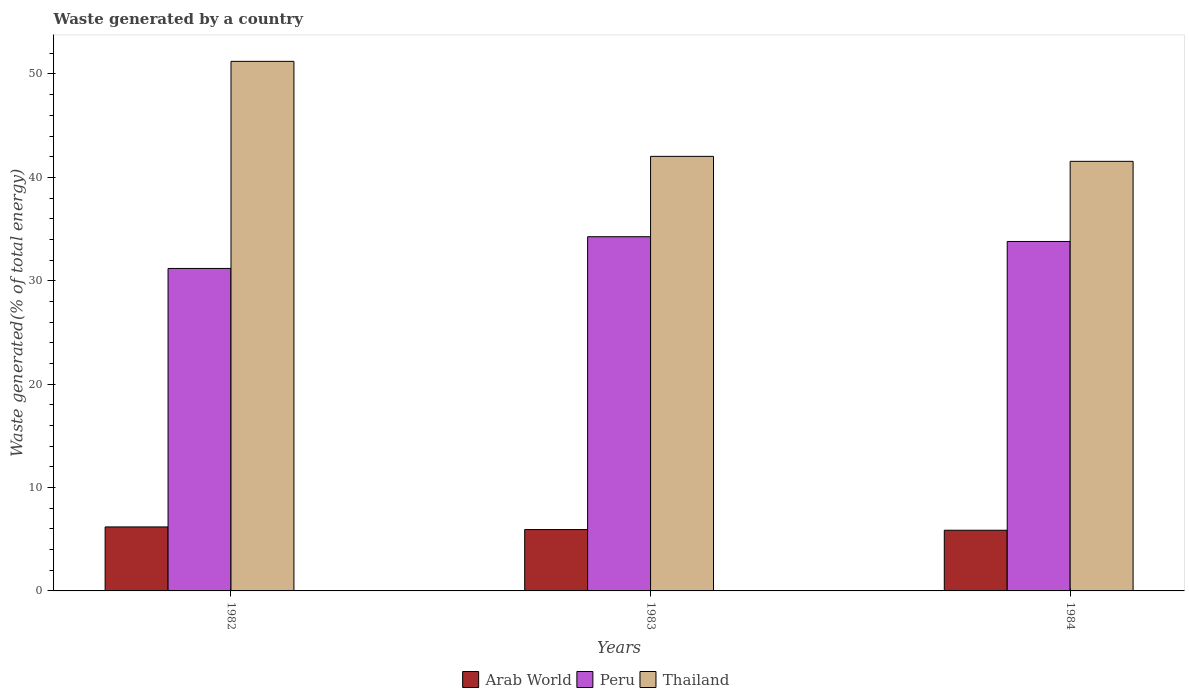How many different coloured bars are there?
Ensure brevity in your answer.  3. Are the number of bars per tick equal to the number of legend labels?
Provide a succinct answer. Yes. How many bars are there on the 2nd tick from the left?
Ensure brevity in your answer.  3. How many bars are there on the 1st tick from the right?
Your response must be concise. 3. What is the label of the 2nd group of bars from the left?
Make the answer very short. 1983. What is the total waste generated in Thailand in 1982?
Ensure brevity in your answer.  51.22. Across all years, what is the maximum total waste generated in Arab World?
Your answer should be compact. 6.19. Across all years, what is the minimum total waste generated in Peru?
Keep it short and to the point. 31.19. What is the total total waste generated in Peru in the graph?
Make the answer very short. 99.25. What is the difference between the total waste generated in Peru in 1982 and that in 1984?
Keep it short and to the point. -2.61. What is the difference between the total waste generated in Peru in 1982 and the total waste generated in Thailand in 1983?
Ensure brevity in your answer.  -10.84. What is the average total waste generated in Peru per year?
Your answer should be very brief. 33.08. In the year 1983, what is the difference between the total waste generated in Peru and total waste generated in Thailand?
Your response must be concise. -7.77. What is the ratio of the total waste generated in Peru in 1982 to that in 1984?
Give a very brief answer. 0.92. Is the total waste generated in Peru in 1983 less than that in 1984?
Your response must be concise. No. What is the difference between the highest and the second highest total waste generated in Arab World?
Keep it short and to the point. 0.25. What is the difference between the highest and the lowest total waste generated in Peru?
Your answer should be very brief. 3.07. What does the 2nd bar from the left in 1983 represents?
Make the answer very short. Peru. What does the 3rd bar from the right in 1984 represents?
Keep it short and to the point. Arab World. Is it the case that in every year, the sum of the total waste generated in Thailand and total waste generated in Peru is greater than the total waste generated in Arab World?
Your answer should be very brief. Yes. Are all the bars in the graph horizontal?
Give a very brief answer. No. Are the values on the major ticks of Y-axis written in scientific E-notation?
Your answer should be compact. No. Does the graph contain grids?
Your answer should be compact. No. Where does the legend appear in the graph?
Your answer should be compact. Bottom center. How are the legend labels stacked?
Your response must be concise. Horizontal. What is the title of the graph?
Offer a terse response. Waste generated by a country. What is the label or title of the X-axis?
Provide a short and direct response. Years. What is the label or title of the Y-axis?
Your answer should be compact. Waste generated(% of total energy). What is the Waste generated(% of total energy) of Arab World in 1982?
Provide a succinct answer. 6.19. What is the Waste generated(% of total energy) of Peru in 1982?
Make the answer very short. 31.19. What is the Waste generated(% of total energy) of Thailand in 1982?
Offer a very short reply. 51.22. What is the Waste generated(% of total energy) of Arab World in 1983?
Ensure brevity in your answer.  5.94. What is the Waste generated(% of total energy) of Peru in 1983?
Your answer should be compact. 34.26. What is the Waste generated(% of total energy) of Thailand in 1983?
Give a very brief answer. 42.03. What is the Waste generated(% of total energy) of Arab World in 1984?
Keep it short and to the point. 5.87. What is the Waste generated(% of total energy) in Peru in 1984?
Make the answer very short. 33.8. What is the Waste generated(% of total energy) in Thailand in 1984?
Offer a very short reply. 41.55. Across all years, what is the maximum Waste generated(% of total energy) in Arab World?
Keep it short and to the point. 6.19. Across all years, what is the maximum Waste generated(% of total energy) in Peru?
Give a very brief answer. 34.26. Across all years, what is the maximum Waste generated(% of total energy) of Thailand?
Offer a very short reply. 51.22. Across all years, what is the minimum Waste generated(% of total energy) in Arab World?
Give a very brief answer. 5.87. Across all years, what is the minimum Waste generated(% of total energy) in Peru?
Your response must be concise. 31.19. Across all years, what is the minimum Waste generated(% of total energy) in Thailand?
Your response must be concise. 41.55. What is the total Waste generated(% of total energy) in Arab World in the graph?
Your answer should be compact. 17.99. What is the total Waste generated(% of total energy) of Peru in the graph?
Your response must be concise. 99.25. What is the total Waste generated(% of total energy) in Thailand in the graph?
Your answer should be compact. 134.8. What is the difference between the Waste generated(% of total energy) of Arab World in 1982 and that in 1983?
Your response must be concise. 0.25. What is the difference between the Waste generated(% of total energy) in Peru in 1982 and that in 1983?
Provide a succinct answer. -3.07. What is the difference between the Waste generated(% of total energy) of Thailand in 1982 and that in 1983?
Make the answer very short. 9.19. What is the difference between the Waste generated(% of total energy) of Arab World in 1982 and that in 1984?
Offer a very short reply. 0.32. What is the difference between the Waste generated(% of total energy) in Peru in 1982 and that in 1984?
Provide a succinct answer. -2.61. What is the difference between the Waste generated(% of total energy) of Thailand in 1982 and that in 1984?
Provide a short and direct response. 9.67. What is the difference between the Waste generated(% of total energy) of Arab World in 1983 and that in 1984?
Your answer should be compact. 0.07. What is the difference between the Waste generated(% of total energy) of Peru in 1983 and that in 1984?
Your answer should be compact. 0.46. What is the difference between the Waste generated(% of total energy) of Thailand in 1983 and that in 1984?
Keep it short and to the point. 0.48. What is the difference between the Waste generated(% of total energy) in Arab World in 1982 and the Waste generated(% of total energy) in Peru in 1983?
Give a very brief answer. -28.07. What is the difference between the Waste generated(% of total energy) in Arab World in 1982 and the Waste generated(% of total energy) in Thailand in 1983?
Make the answer very short. -35.84. What is the difference between the Waste generated(% of total energy) of Peru in 1982 and the Waste generated(% of total energy) of Thailand in 1983?
Offer a very short reply. -10.84. What is the difference between the Waste generated(% of total energy) of Arab World in 1982 and the Waste generated(% of total energy) of Peru in 1984?
Keep it short and to the point. -27.61. What is the difference between the Waste generated(% of total energy) of Arab World in 1982 and the Waste generated(% of total energy) of Thailand in 1984?
Make the answer very short. -35.36. What is the difference between the Waste generated(% of total energy) in Peru in 1982 and the Waste generated(% of total energy) in Thailand in 1984?
Your response must be concise. -10.36. What is the difference between the Waste generated(% of total energy) of Arab World in 1983 and the Waste generated(% of total energy) of Peru in 1984?
Your answer should be very brief. -27.86. What is the difference between the Waste generated(% of total energy) in Arab World in 1983 and the Waste generated(% of total energy) in Thailand in 1984?
Offer a terse response. -35.61. What is the difference between the Waste generated(% of total energy) of Peru in 1983 and the Waste generated(% of total energy) of Thailand in 1984?
Offer a very short reply. -7.29. What is the average Waste generated(% of total energy) of Arab World per year?
Provide a succinct answer. 6. What is the average Waste generated(% of total energy) of Peru per year?
Offer a very short reply. 33.08. What is the average Waste generated(% of total energy) of Thailand per year?
Provide a short and direct response. 44.93. In the year 1982, what is the difference between the Waste generated(% of total energy) in Arab World and Waste generated(% of total energy) in Peru?
Ensure brevity in your answer.  -25. In the year 1982, what is the difference between the Waste generated(% of total energy) of Arab World and Waste generated(% of total energy) of Thailand?
Ensure brevity in your answer.  -45.03. In the year 1982, what is the difference between the Waste generated(% of total energy) of Peru and Waste generated(% of total energy) of Thailand?
Provide a short and direct response. -20.03. In the year 1983, what is the difference between the Waste generated(% of total energy) of Arab World and Waste generated(% of total energy) of Peru?
Give a very brief answer. -28.32. In the year 1983, what is the difference between the Waste generated(% of total energy) of Arab World and Waste generated(% of total energy) of Thailand?
Make the answer very short. -36.09. In the year 1983, what is the difference between the Waste generated(% of total energy) of Peru and Waste generated(% of total energy) of Thailand?
Your answer should be compact. -7.77. In the year 1984, what is the difference between the Waste generated(% of total energy) in Arab World and Waste generated(% of total energy) in Peru?
Offer a very short reply. -27.93. In the year 1984, what is the difference between the Waste generated(% of total energy) of Arab World and Waste generated(% of total energy) of Thailand?
Your response must be concise. -35.68. In the year 1984, what is the difference between the Waste generated(% of total energy) of Peru and Waste generated(% of total energy) of Thailand?
Provide a succinct answer. -7.75. What is the ratio of the Waste generated(% of total energy) in Arab World in 1982 to that in 1983?
Ensure brevity in your answer.  1.04. What is the ratio of the Waste generated(% of total energy) of Peru in 1982 to that in 1983?
Your response must be concise. 0.91. What is the ratio of the Waste generated(% of total energy) in Thailand in 1982 to that in 1983?
Keep it short and to the point. 1.22. What is the ratio of the Waste generated(% of total energy) of Arab World in 1982 to that in 1984?
Ensure brevity in your answer.  1.05. What is the ratio of the Waste generated(% of total energy) in Peru in 1982 to that in 1984?
Your answer should be compact. 0.92. What is the ratio of the Waste generated(% of total energy) of Thailand in 1982 to that in 1984?
Provide a short and direct response. 1.23. What is the ratio of the Waste generated(% of total energy) of Arab World in 1983 to that in 1984?
Provide a succinct answer. 1.01. What is the ratio of the Waste generated(% of total energy) in Peru in 1983 to that in 1984?
Provide a short and direct response. 1.01. What is the ratio of the Waste generated(% of total energy) of Thailand in 1983 to that in 1984?
Your response must be concise. 1.01. What is the difference between the highest and the second highest Waste generated(% of total energy) of Arab World?
Make the answer very short. 0.25. What is the difference between the highest and the second highest Waste generated(% of total energy) in Peru?
Provide a short and direct response. 0.46. What is the difference between the highest and the second highest Waste generated(% of total energy) in Thailand?
Your answer should be very brief. 9.19. What is the difference between the highest and the lowest Waste generated(% of total energy) of Arab World?
Offer a terse response. 0.32. What is the difference between the highest and the lowest Waste generated(% of total energy) in Peru?
Offer a very short reply. 3.07. What is the difference between the highest and the lowest Waste generated(% of total energy) of Thailand?
Make the answer very short. 9.67. 